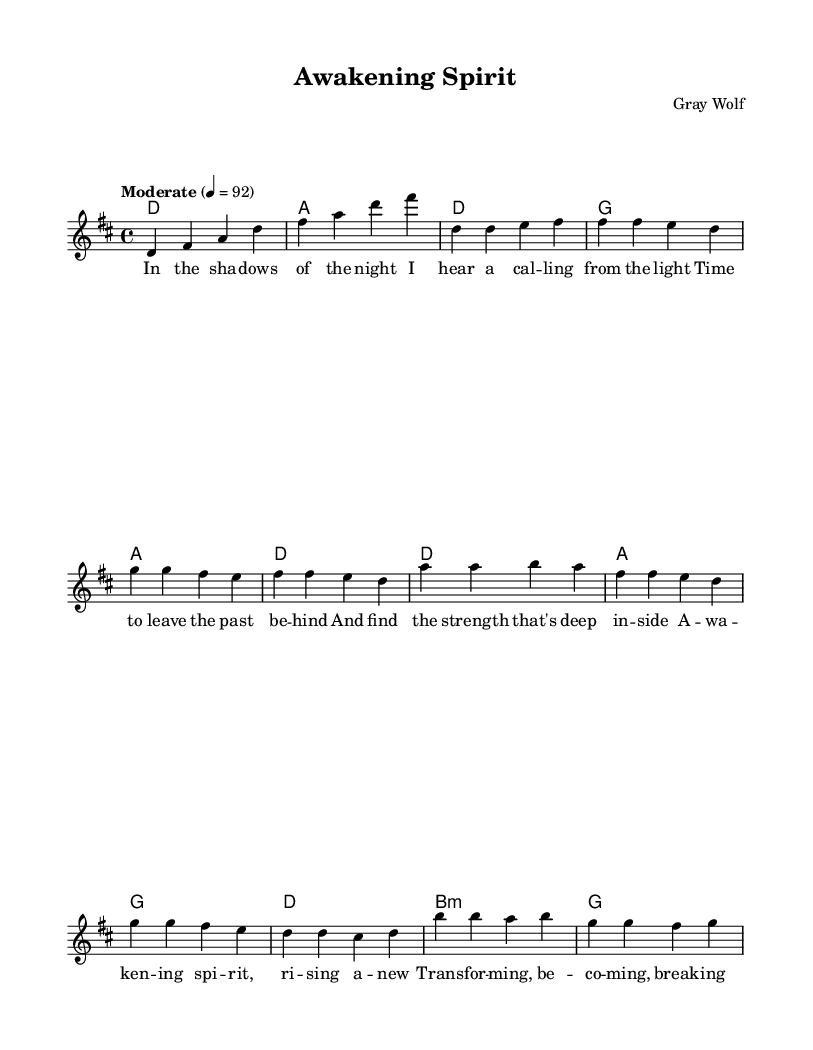What is the key signature of this music? The key signature is indicated at the beginning of the sheet music. It shows two sharps, which corresponds to D major.
Answer: D major What is the time signature of this music? The time signature is found at the beginning of the piece, indicating that there are four beats per measure. This is represented as 4/4.
Answer: 4/4 What is the tempo marking for this music? The tempo is specified in the score, where it indicates "Moderate" with a specific metronome marking of 92 beats per minute.
Answer: Moderate, 92 How many measures are in the chorus? To find the number of measures in the chorus, we look at the chorus section lyrics and count the measures below it in the melody; there are four measures shown.
Answer: 4 What chord is played during the bridge? The bridge section indicates a B minor chord followed by a G major chord. The indication shown is B1:m for B minor.
Answer: B minor What theme does the lyrics of the first verse encompass? The first verse lyrics discuss leaving the past behind and finding inner strength, which reflects themes of transformation and new beginnings.
Answer: Transformation What is the primary message of the chorus? The chorus conveys the message of awakening and spiritual transformation, emphasizing the idea of rising anew and breaking through.
Answer: Awakening spirit 